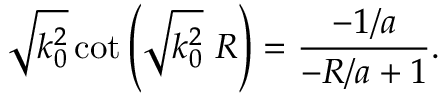Convert formula to latex. <formula><loc_0><loc_0><loc_500><loc_500>\sqrt { k _ { 0 } ^ { 2 } } \cot \left ( \sqrt { k _ { 0 } ^ { 2 } } \ R \right ) = \frac { - 1 / a } { - R / a + 1 } .</formula> 